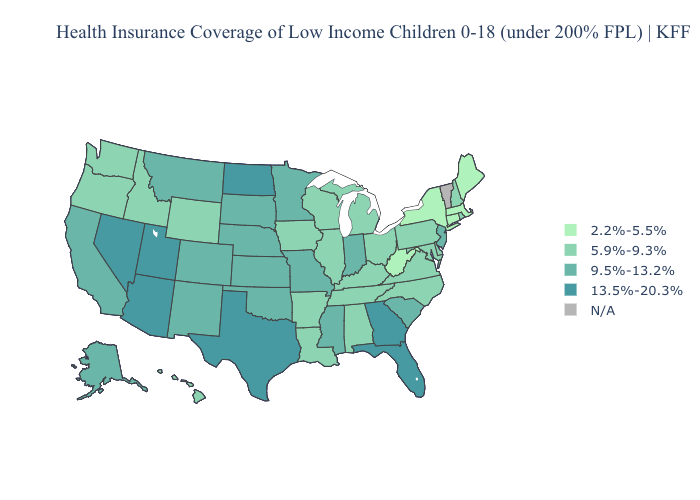Does the first symbol in the legend represent the smallest category?
Quick response, please. Yes. Among the states that border Nebraska , which have the highest value?
Write a very short answer. Colorado, Kansas, Missouri, South Dakota. What is the highest value in the Northeast ?
Give a very brief answer. 9.5%-13.2%. Name the states that have a value in the range 2.2%-5.5%?
Answer briefly. Connecticut, Maine, Massachusetts, New York, West Virginia. Which states have the highest value in the USA?
Quick response, please. Arizona, Florida, Georgia, Nevada, North Dakota, Texas, Utah. Does Texas have the highest value in the USA?
Keep it brief. Yes. What is the value of Pennsylvania?
Keep it brief. 5.9%-9.3%. What is the value of Wisconsin?
Keep it brief. 5.9%-9.3%. Name the states that have a value in the range 9.5%-13.2%?
Keep it brief. Alaska, California, Colorado, Indiana, Kansas, Minnesota, Mississippi, Missouri, Montana, Nebraska, New Jersey, New Mexico, Oklahoma, South Carolina, South Dakota. Name the states that have a value in the range 2.2%-5.5%?
Keep it brief. Connecticut, Maine, Massachusetts, New York, West Virginia. What is the value of West Virginia?
Be succinct. 2.2%-5.5%. Name the states that have a value in the range 13.5%-20.3%?
Give a very brief answer. Arizona, Florida, Georgia, Nevada, North Dakota, Texas, Utah. Which states hav the highest value in the South?
Concise answer only. Florida, Georgia, Texas. 